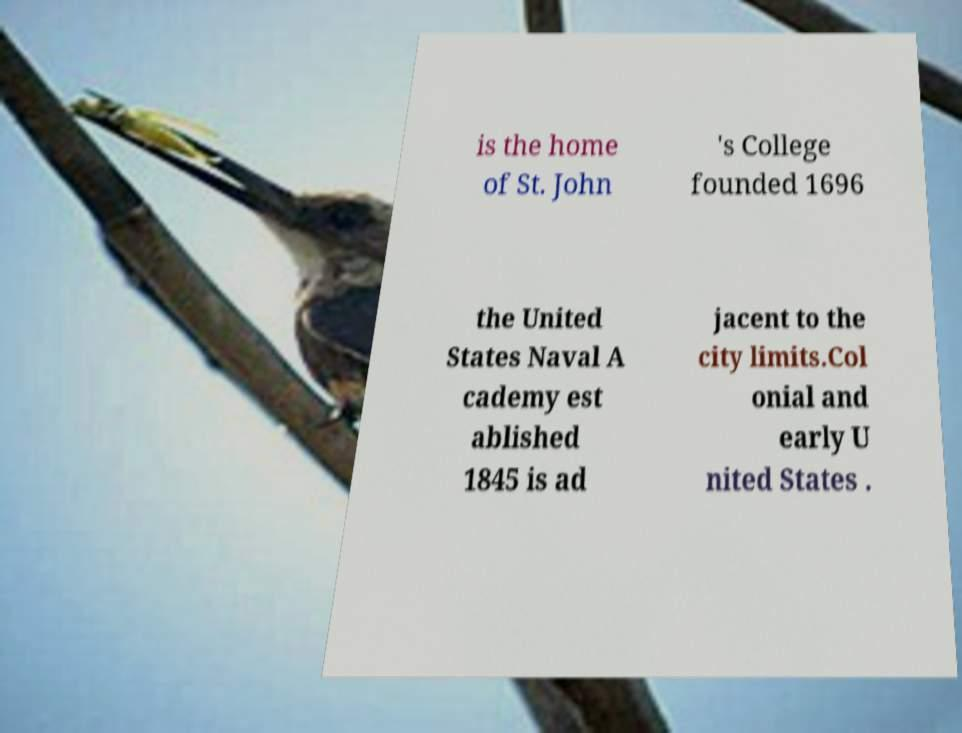I need the written content from this picture converted into text. Can you do that? is the home of St. John 's College founded 1696 the United States Naval A cademy est ablished 1845 is ad jacent to the city limits.Col onial and early U nited States . 